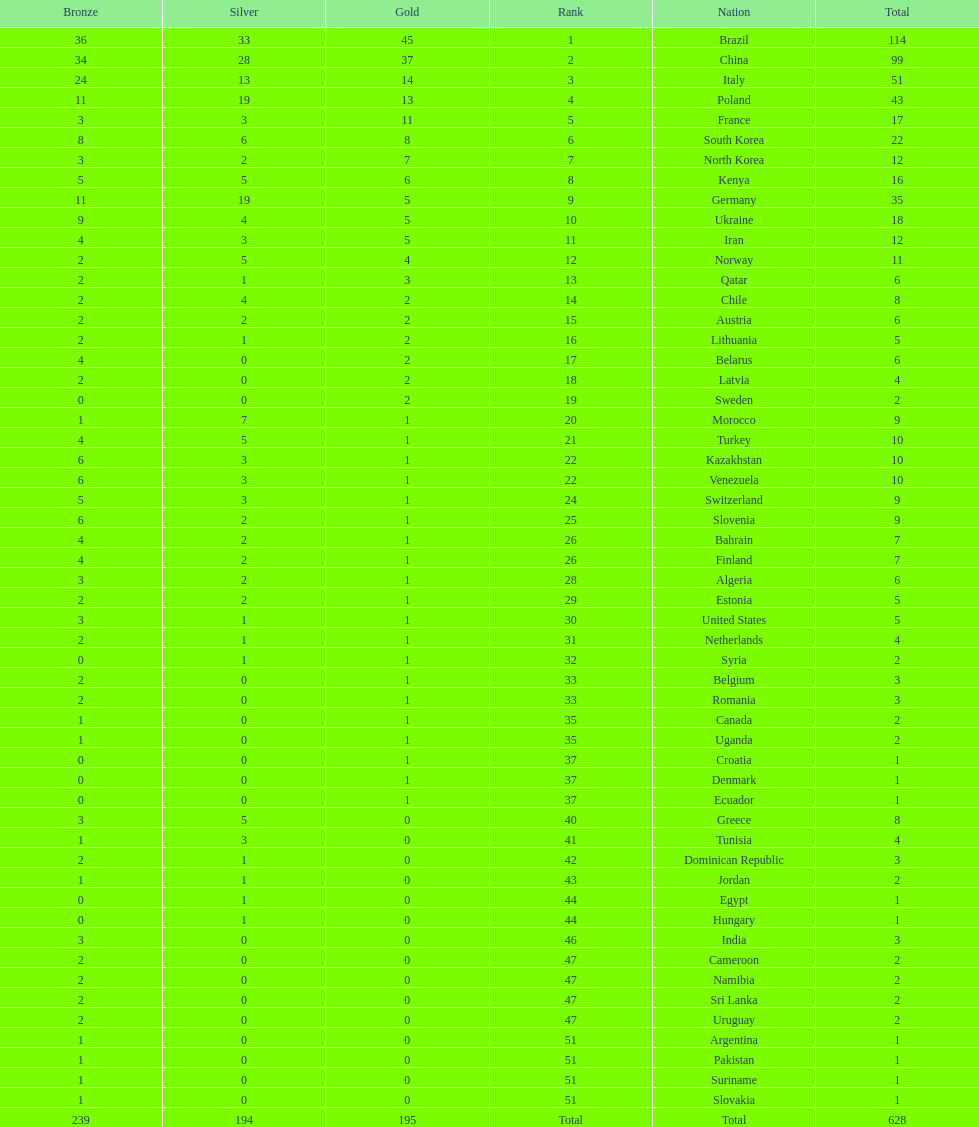Who won more gold medals, brazil or china? Brazil. 